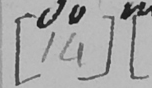What text is written in this handwritten line? [ 14 ]   [ 